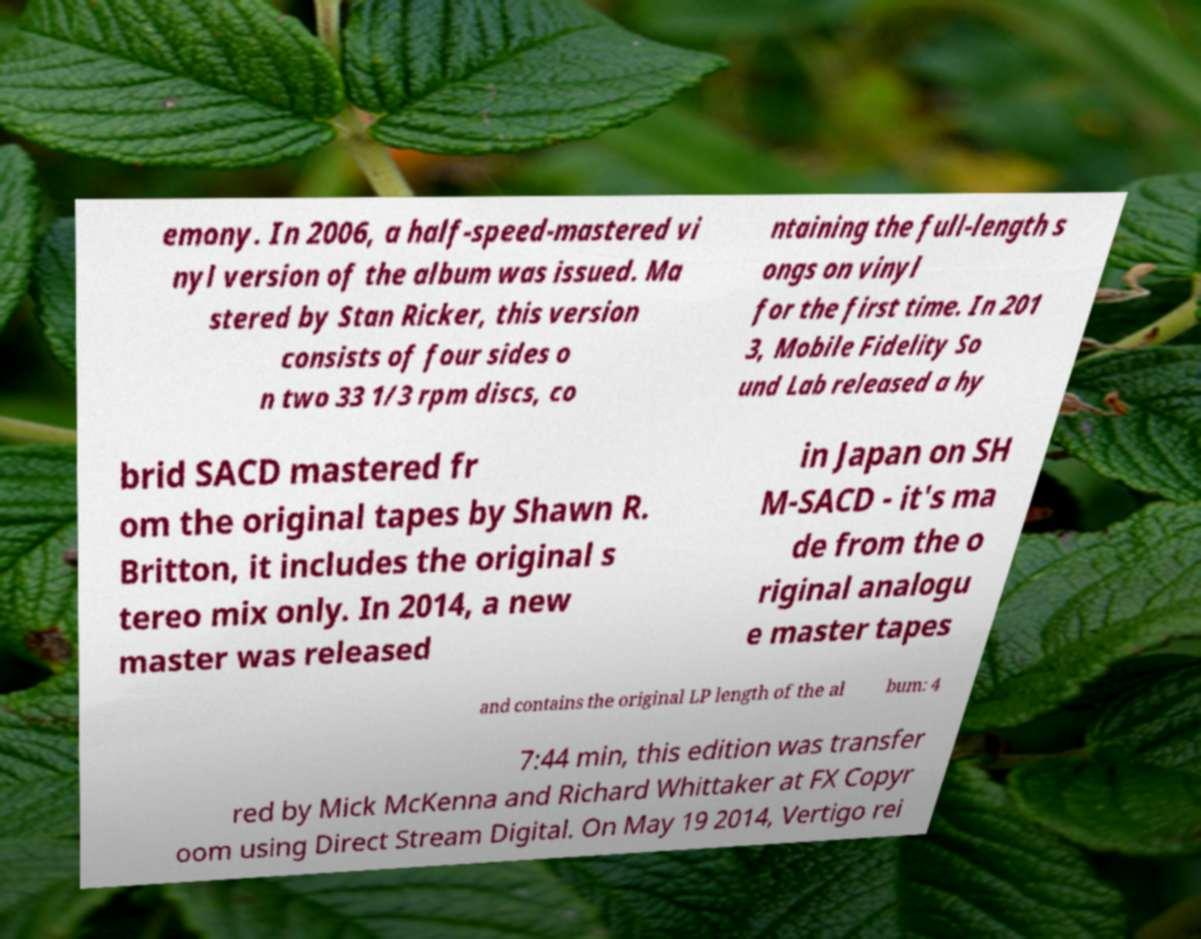There's text embedded in this image that I need extracted. Can you transcribe it verbatim? emony. In 2006, a half-speed-mastered vi nyl version of the album was issued. Ma stered by Stan Ricker, this version consists of four sides o n two 33 1/3 rpm discs, co ntaining the full-length s ongs on vinyl for the first time. In 201 3, Mobile Fidelity So und Lab released a hy brid SACD mastered fr om the original tapes by Shawn R. Britton, it includes the original s tereo mix only. In 2014, a new master was released in Japan on SH M-SACD - it's ma de from the o riginal analogu e master tapes and contains the original LP length of the al bum: 4 7:44 min, this edition was transfer red by Mick McKenna and Richard Whittaker at FX Copyr oom using Direct Stream Digital. On May 19 2014, Vertigo rei 